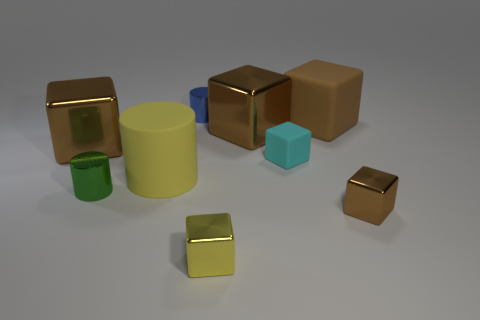How many objects are either large rubber things that are left of the large brown rubber object or metal blocks that are behind the big yellow cylinder?
Offer a terse response. 3. Is the small yellow cube made of the same material as the brown cube in front of the large cylinder?
Offer a very short reply. Yes. There is a small thing that is right of the yellow shiny block and in front of the large cylinder; what is its shape?
Your answer should be compact. Cube. How many other objects are there of the same color as the matte cylinder?
Your answer should be compact. 1. There is a tiny cyan thing; what shape is it?
Your response must be concise. Cube. There is a cube that is in front of the metal cube on the right side of the tiny cyan object; what is its color?
Provide a short and direct response. Yellow. There is a large cylinder; is its color the same as the tiny metal thing in front of the tiny brown object?
Keep it short and to the point. Yes. There is a brown cube that is to the right of the small cyan object and behind the small rubber cube; what is its material?
Provide a short and direct response. Rubber. Are there any other objects that have the same size as the cyan rubber thing?
Give a very brief answer. Yes. There is a green object that is the same size as the yellow shiny thing; what is it made of?
Offer a terse response. Metal. 